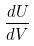Convert formula to latex. <formula><loc_0><loc_0><loc_500><loc_500>\frac { d U } { d V }</formula> 